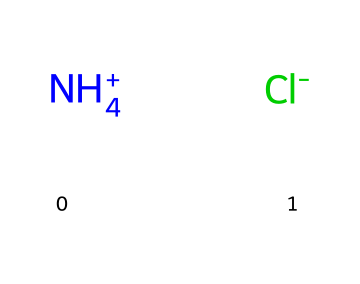What is the central atom in this ionic liquid? The chemical structure shows the ammonium ion, which consists of one nitrogen atom that is central due to its bonding with four hydrogen atoms.
Answer: nitrogen How many hydrogen atoms are present in this ionic liquid? In the structure, the ammonium ion is represented with four hydrogen atoms attached to the nitrogen atom.
Answer: four What type of ion is represented by [NH4+]? The cation [NH4+] represents an ammonium ion, which is a positively charged polyatomic ion with one nitrogen atom and four hydrogen atoms.
Answer: ammonium What does the presence of [Cl-] indicate about this ionic liquid? The presence of [Cl-] indicates that this ionic liquid contains a chloride anion, which is necessary for ionic balance with the ammonium cation.
Answer: chloride Why are ammonium-based ionic liquids effective in air purification? Ammonium-based ionic liquids can react with various pollutants due to their ionic nature and composition, enabling efficient capture and removal of contaminants from the air.
Answer: reactive How do the positive and negative charges in this ionic liquid affect its properties? The positive charge on [NH4+] and the negative charge on [Cl-] create an electrostatic attraction, resulting in a low vapor pressure characteristic of ionic liquids, making them stable and suitable for various applications.
Answer: low vapor pressure 